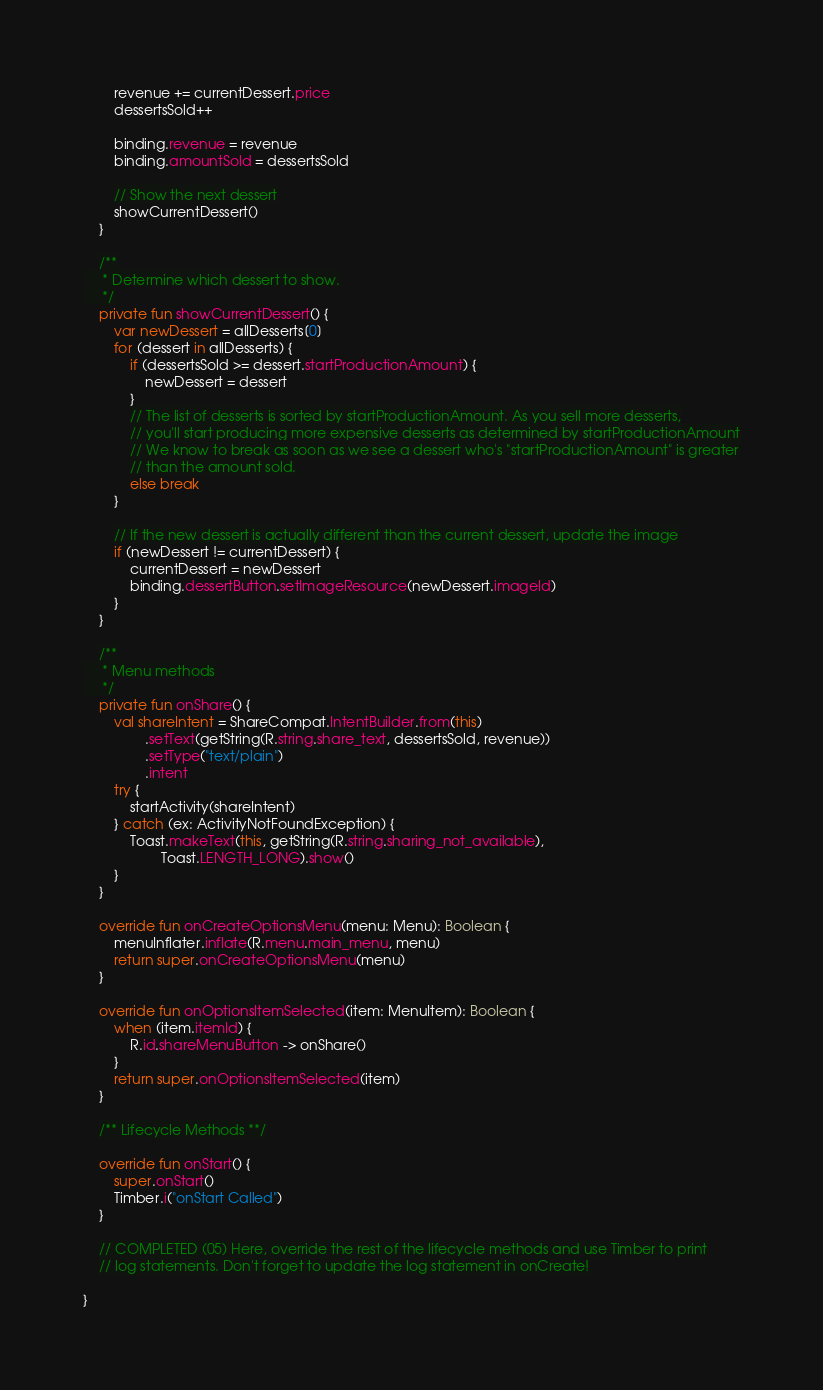<code> <loc_0><loc_0><loc_500><loc_500><_Kotlin_>        revenue += currentDessert.price
        dessertsSold++

        binding.revenue = revenue
        binding.amountSold = dessertsSold

        // Show the next dessert
        showCurrentDessert()
    }

    /**
     * Determine which dessert to show.
     */
    private fun showCurrentDessert() {
        var newDessert = allDesserts[0]
        for (dessert in allDesserts) {
            if (dessertsSold >= dessert.startProductionAmount) {
                newDessert = dessert
            }
            // The list of desserts is sorted by startProductionAmount. As you sell more desserts,
            // you'll start producing more expensive desserts as determined by startProductionAmount
            // We know to break as soon as we see a dessert who's "startProductionAmount" is greater
            // than the amount sold.
            else break
        }

        // If the new dessert is actually different than the current dessert, update the image
        if (newDessert != currentDessert) {
            currentDessert = newDessert
            binding.dessertButton.setImageResource(newDessert.imageId)
        }
    }

    /**
     * Menu methods
     */
    private fun onShare() {
        val shareIntent = ShareCompat.IntentBuilder.from(this)
                .setText(getString(R.string.share_text, dessertsSold, revenue))
                .setType("text/plain")
                .intent
        try {
            startActivity(shareIntent)
        } catch (ex: ActivityNotFoundException) {
            Toast.makeText(this, getString(R.string.sharing_not_available),
                    Toast.LENGTH_LONG).show()
        }
    }

    override fun onCreateOptionsMenu(menu: Menu): Boolean {
        menuInflater.inflate(R.menu.main_menu, menu)
        return super.onCreateOptionsMenu(menu)
    }

    override fun onOptionsItemSelected(item: MenuItem): Boolean {
        when (item.itemId) {
            R.id.shareMenuButton -> onShare()
        }
        return super.onOptionsItemSelected(item)
    }

    /** Lifecycle Methods **/

    override fun onStart() {
        super.onStart()
        Timber.i("onStart Called")
    }

    // COMPLETED (05) Here, override the rest of the lifecycle methods and use Timber to print
    // log statements. Don't forget to update the log statement in onCreate!

}
</code> 